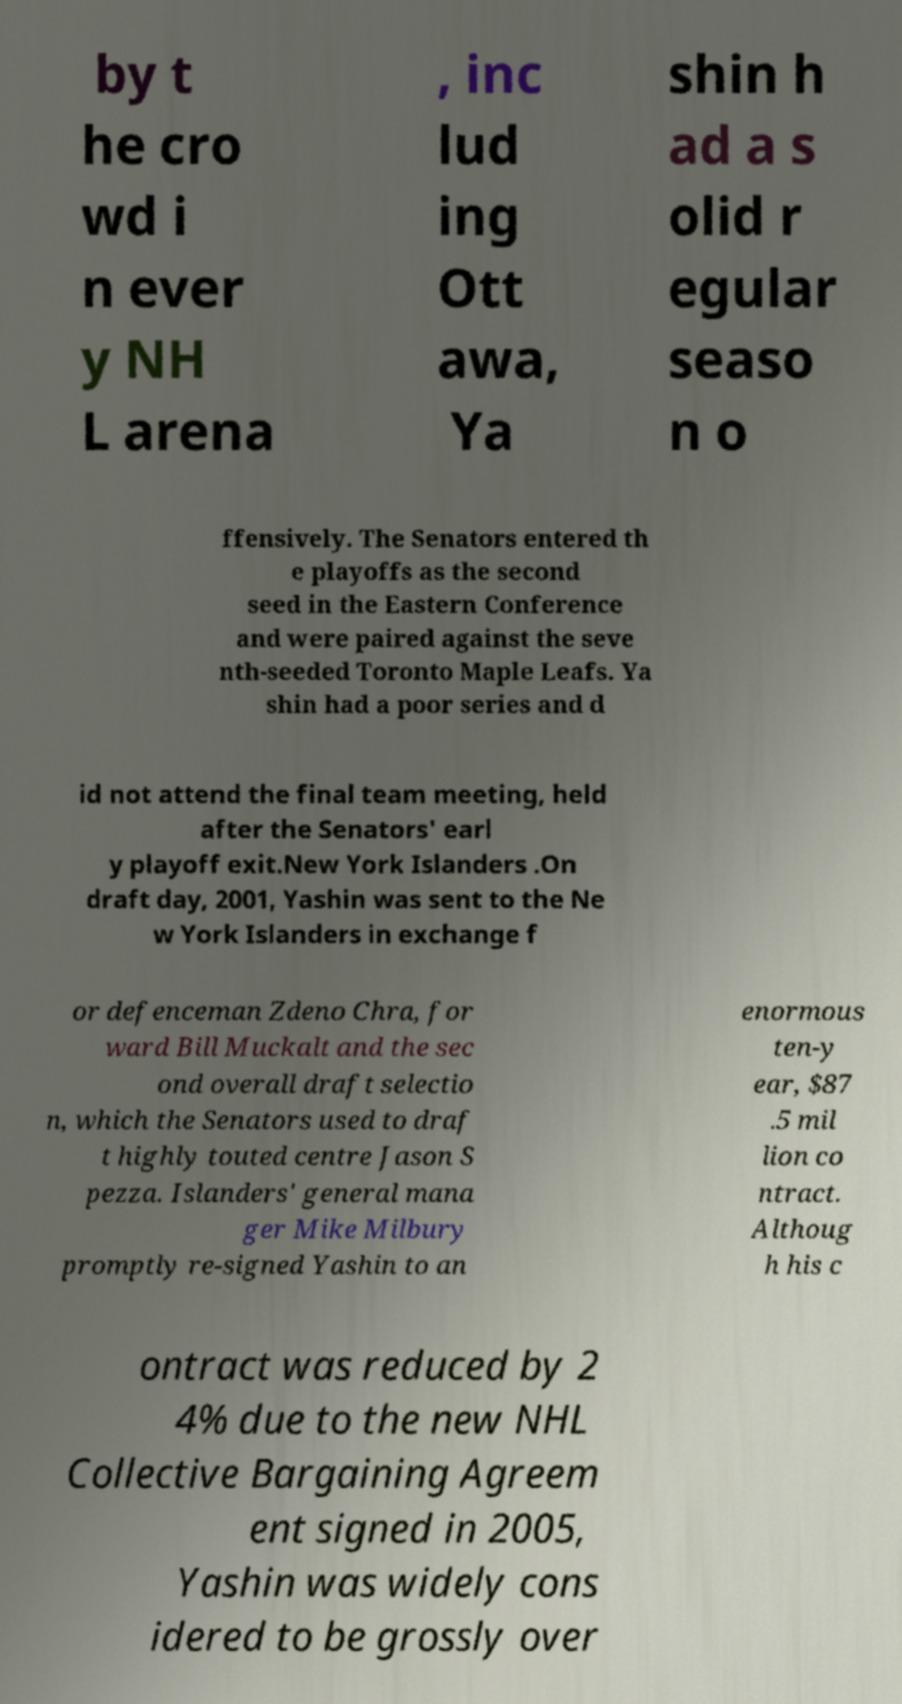There's text embedded in this image that I need extracted. Can you transcribe it verbatim? by t he cro wd i n ever y NH L arena , inc lud ing Ott awa, Ya shin h ad a s olid r egular seaso n o ffensively. The Senators entered th e playoffs as the second seed in the Eastern Conference and were paired against the seve nth-seeded Toronto Maple Leafs. Ya shin had a poor series and d id not attend the final team meeting, held after the Senators' earl y playoff exit.New York Islanders .On draft day, 2001, Yashin was sent to the Ne w York Islanders in exchange f or defenceman Zdeno Chra, for ward Bill Muckalt and the sec ond overall draft selectio n, which the Senators used to draf t highly touted centre Jason S pezza. Islanders' general mana ger Mike Milbury promptly re-signed Yashin to an enormous ten-y ear, $87 .5 mil lion co ntract. Althoug h his c ontract was reduced by 2 4% due to the new NHL Collective Bargaining Agreem ent signed in 2005, Yashin was widely cons idered to be grossly over 